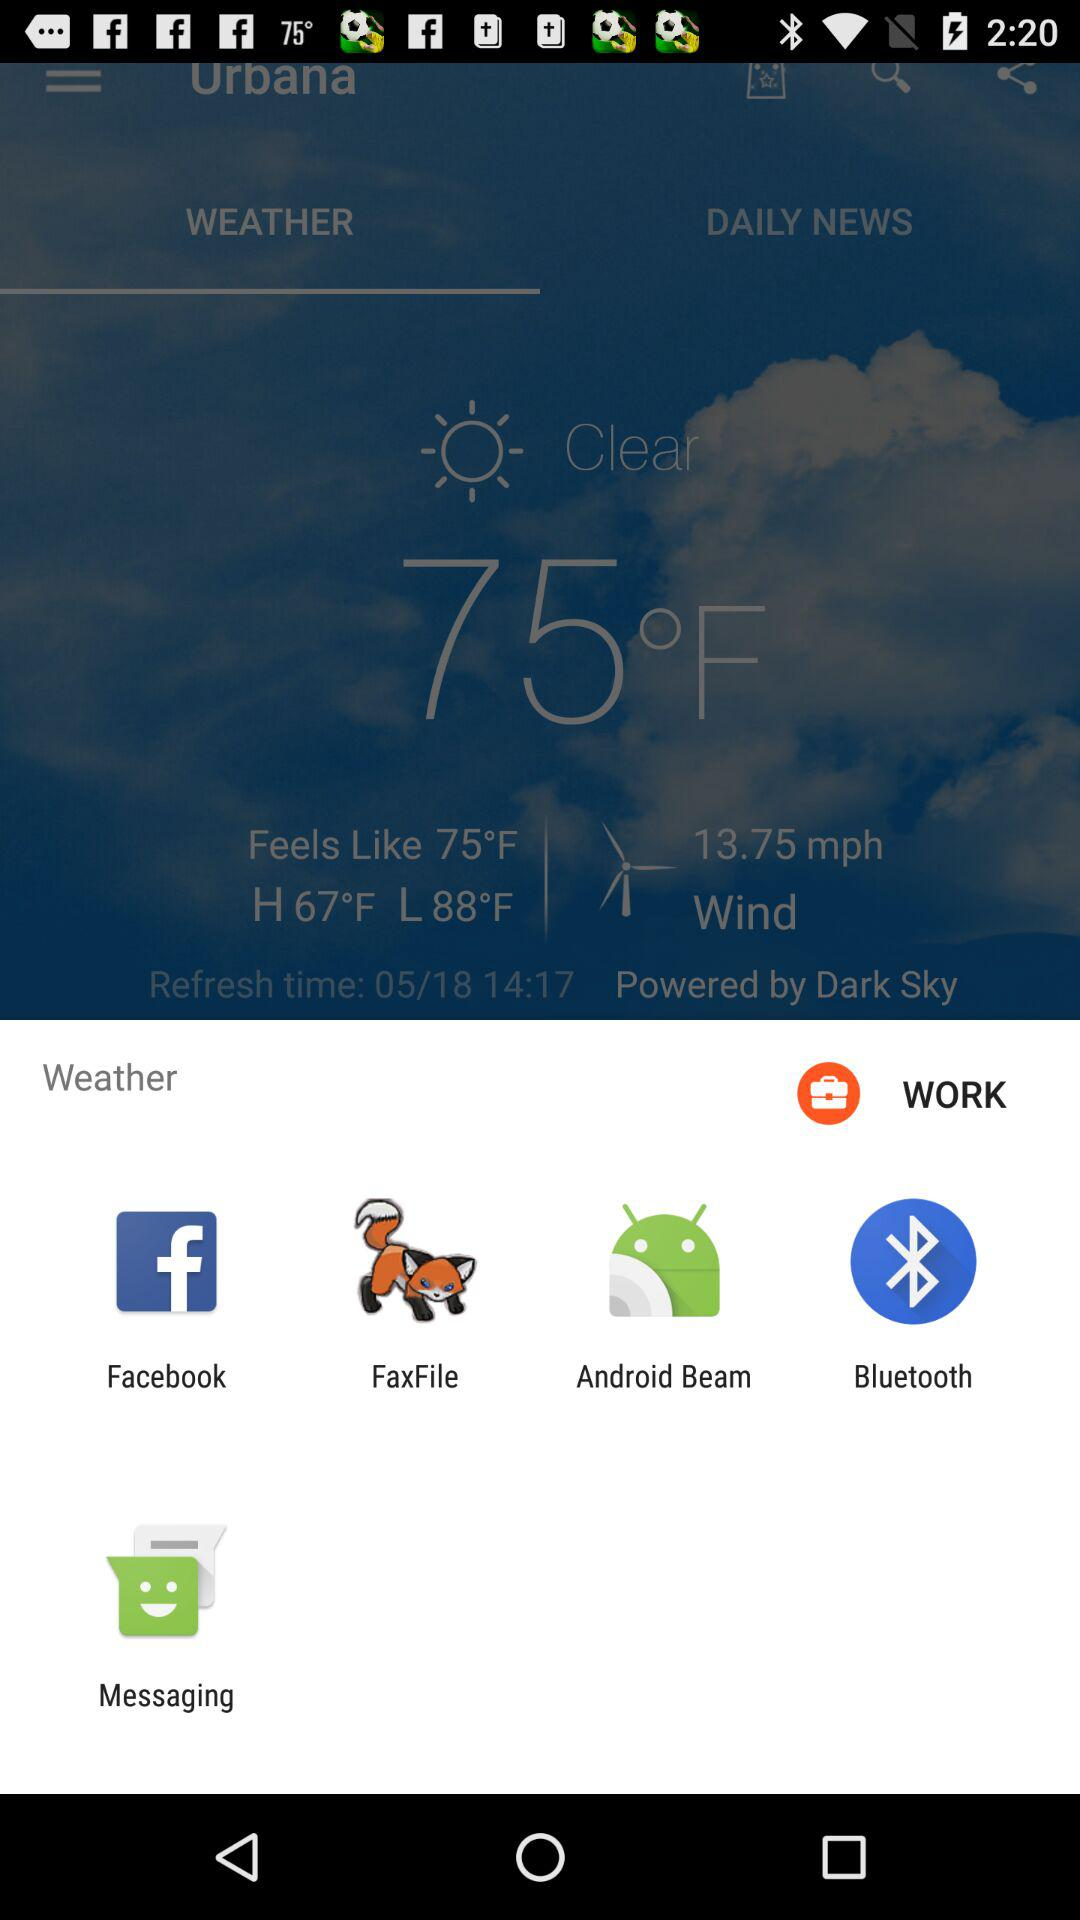What are the different applications through which we can share weather information? You can share weather information through "Facebook", "FaxFile", "Android Beam", "Bluetooth" and "Messaging". 